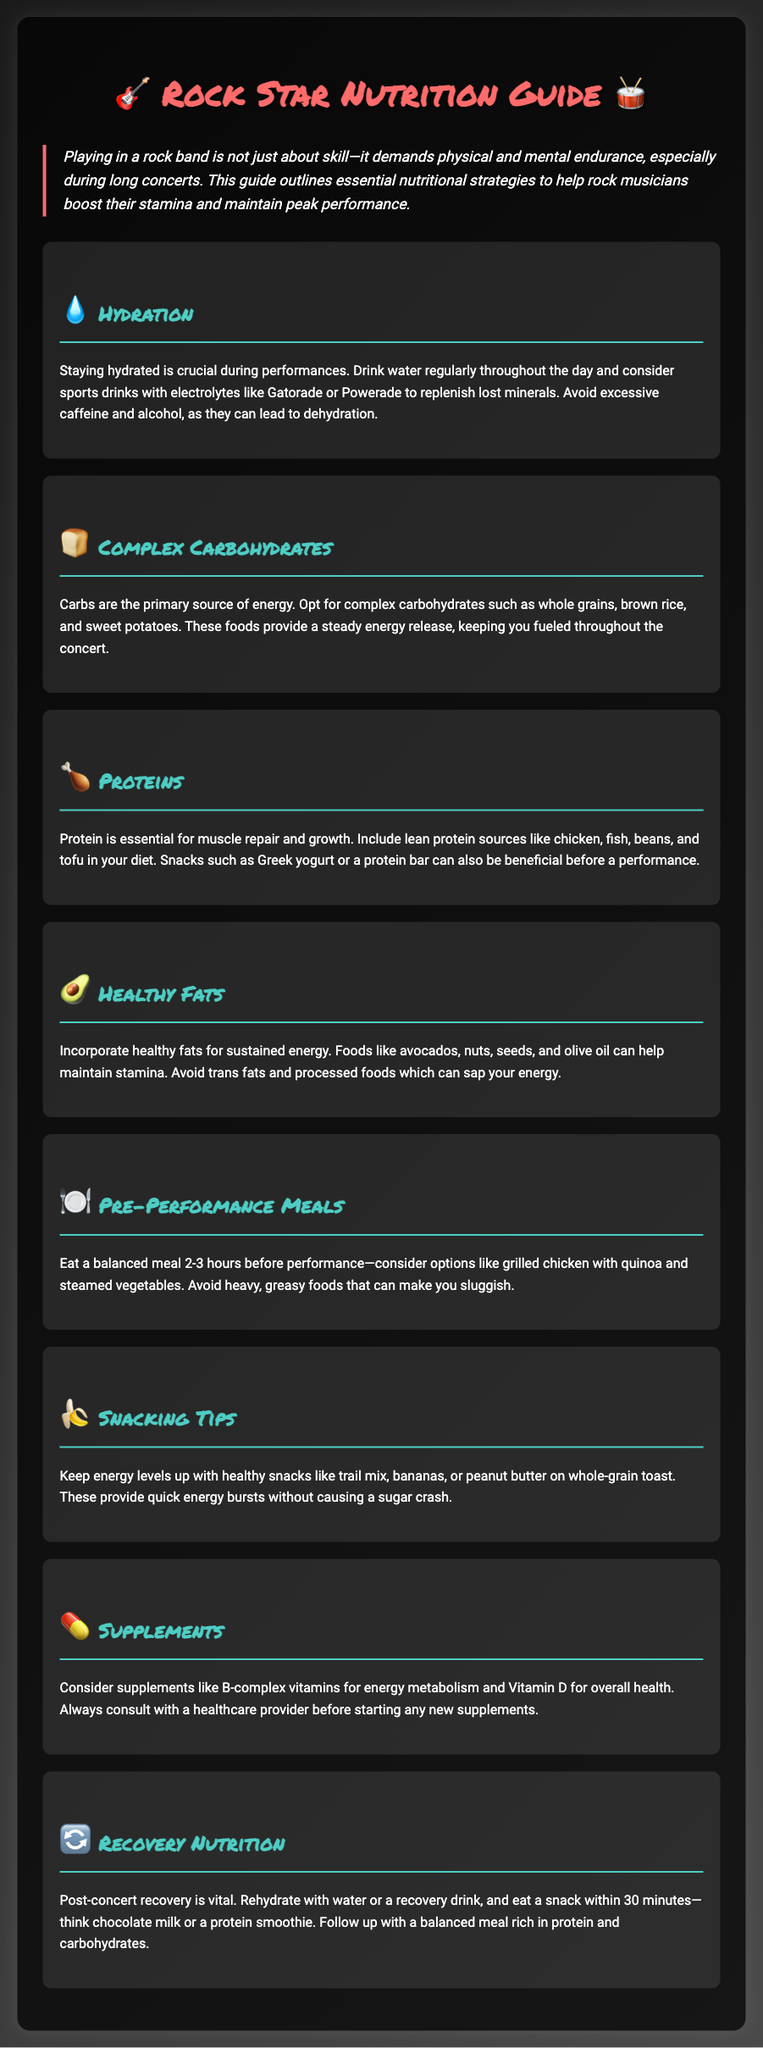what is the title of the document? The title of the document is presented prominently at the top of the rendered page.
Answer: Rock Star Nutrition Guide what are the healthy fat sources mentioned? The document lists specific foods recommended for healthy fats.
Answer: avocados, nuts, seeds, olive oil what is recommended to eat before a performance? The pre-performance meal suggestions are detailed in a specific section of the document.
Answer: grilled chicken with quinoa and steamed vegetables how long before a performance should you eat? The document specifies the time frame for eating before a show.
Answer: 2-3 hours what type of hydration is suggested during performances? Recommendations for hydration during performances are outlined in the hydration section.
Answer: water, sports drinks with electrolytes what is a beneficial post-concert snack? The document suggests a specific recovery snack to consume after performing.
Answer: chocolate milk or a protein smoothie which vitamins are suggested as supplements? The document specifically mentions supplements recommended for energy metabolism and health.
Answer: B-complex vitamins, Vitamin D what is the main energy source for musicians? The document highlights the primary source of energy critical for endurance during performances.
Answer: complex carbohydrates 